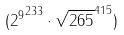<formula> <loc_0><loc_0><loc_500><loc_500>( { 2 ^ { 9 } } ^ { 2 3 3 } \cdot \sqrt { 2 6 5 } ^ { 4 1 5 } )</formula> 